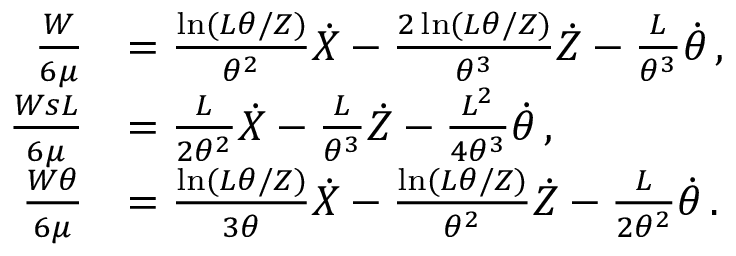Convert formula to latex. <formula><loc_0><loc_0><loc_500><loc_500>\begin{array} { r l } { \frac { W } { 6 \mu } } & { = \frac { \ln ( L \theta / Z ) } { \theta ^ { 2 } } \dot { X } - \frac { 2 \ln ( L \theta / Z ) } { \theta ^ { 3 } } \dot { Z } - \frac { L } { \theta ^ { 3 } } \dot { \theta } \, , } \\ { \frac { W s L } { 6 \mu } } & { = \frac { L } { 2 \theta ^ { 2 } } \dot { X } - \frac { L } { \theta ^ { 3 } } \dot { Z } - \frac { L ^ { 2 } } { 4 \theta ^ { 3 } } \dot { \theta } \, , } \\ { \frac { W \theta } { 6 \mu } } & { = \frac { \ln ( L \theta / Z ) } { 3 \theta } \dot { X } - \frac { \ln ( L \theta / Z ) } { \theta ^ { 2 } } \dot { Z } - \frac { L } { 2 \theta ^ { 2 } } \dot { \theta } \, . } \end{array}</formula> 